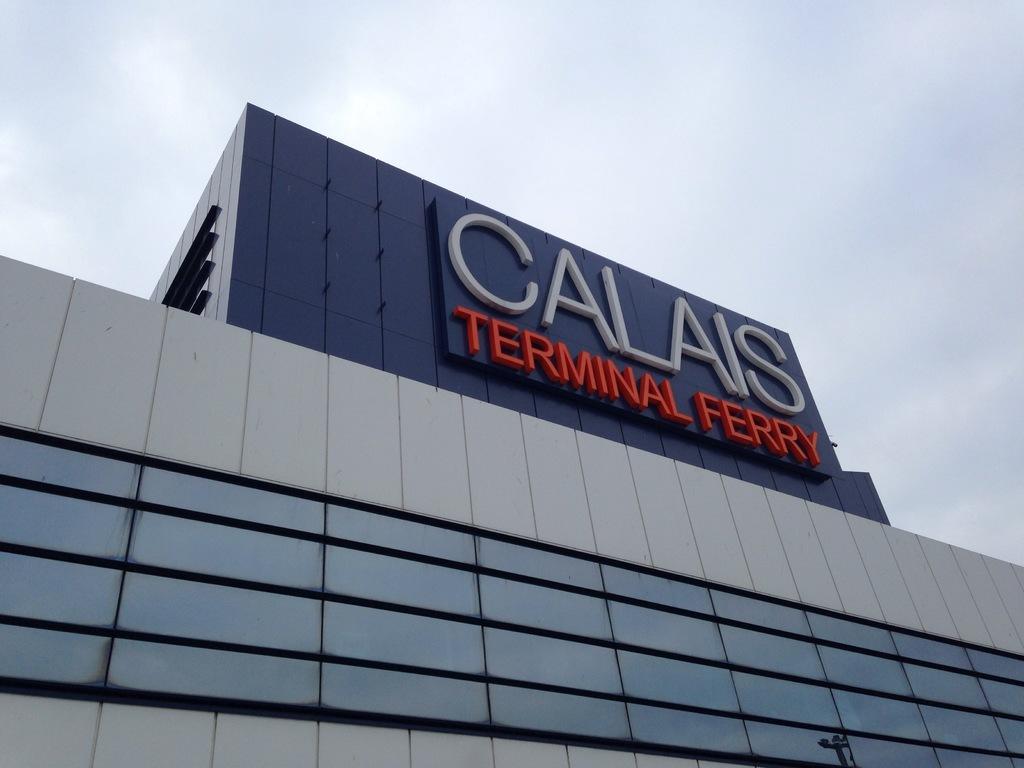Please provide a concise description of this image. This is a building, this is a sky. 